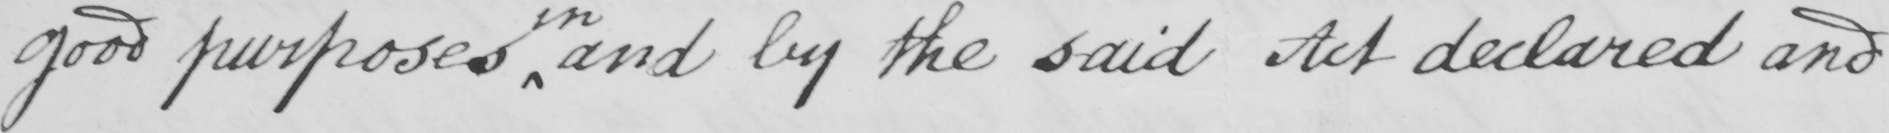Please provide the text content of this handwritten line. good purposes and by the said Act declared and 